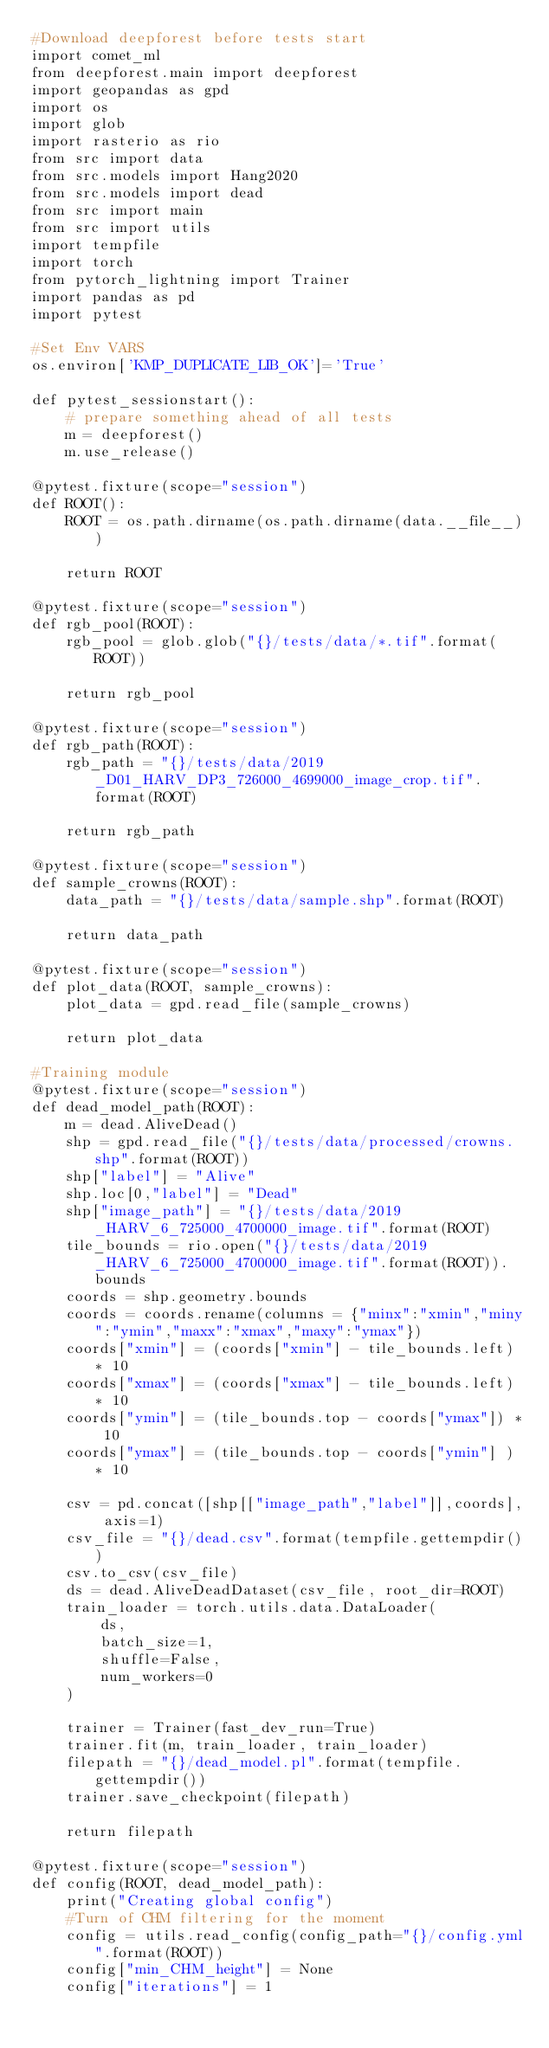Convert code to text. <code><loc_0><loc_0><loc_500><loc_500><_Python_>#Download deepforest before tests start
import comet_ml
from deepforest.main import deepforest
import geopandas as gpd
import os
import glob
import rasterio as rio
from src import data
from src.models import Hang2020
from src.models import dead
from src import main
from src import utils
import tempfile
import torch
from pytorch_lightning import Trainer
import pandas as pd
import pytest

#Set Env VARS
os.environ['KMP_DUPLICATE_LIB_OK']='True'

def pytest_sessionstart():
    # prepare something ahead of all tests
    m = deepforest()
    m.use_release()    

@pytest.fixture(scope="session")
def ROOT():
    ROOT = os.path.dirname(os.path.dirname(data.__file__))
    
    return ROOT

@pytest.fixture(scope="session")
def rgb_pool(ROOT):
    rgb_pool = glob.glob("{}/tests/data/*.tif".format(ROOT))
    
    return rgb_pool

@pytest.fixture(scope="session")
def rgb_path(ROOT):
    rgb_path = "{}/tests/data/2019_D01_HARV_DP3_726000_4699000_image_crop.tif".format(ROOT)
    
    return rgb_path

@pytest.fixture(scope="session")
def sample_crowns(ROOT):
    data_path = "{}/tests/data/sample.shp".format(ROOT)
    
    return data_path

@pytest.fixture(scope="session")
def plot_data(ROOT, sample_crowns):
    plot_data = gpd.read_file(sample_crowns)        
    
    return plot_data

#Training module
@pytest.fixture(scope="session")
def dead_model_path(ROOT):
    m = dead.AliveDead()
    shp = gpd.read_file("{}/tests/data/processed/crowns.shp".format(ROOT))
    shp["label"] = "Alive"
    shp.loc[0,"label"] = "Dead"
    shp["image_path"] = "{}/tests/data/2019_HARV_6_725000_4700000_image.tif".format(ROOT)
    tile_bounds = rio.open("{}/tests/data/2019_HARV_6_725000_4700000_image.tif".format(ROOT)).bounds 
    coords = shp.geometry.bounds
    coords = coords.rename(columns = {"minx":"xmin","miny":"ymin","maxx":"xmax","maxy":"ymax"})
    coords["xmin"] = (coords["xmin"] - tile_bounds.left) * 10
    coords["xmax"] = (coords["xmax"] - tile_bounds.left) * 10
    coords["ymin"] = (tile_bounds.top - coords["ymax"]) * 10
    coords["ymax"] = (tile_bounds.top - coords["ymin"] ) * 10
    
    csv = pd.concat([shp[["image_path","label"]],coords], axis=1)
    csv_file = "{}/dead.csv".format(tempfile.gettempdir())
    csv.to_csv(csv_file)
    ds = dead.AliveDeadDataset(csv_file, root_dir=ROOT)
    train_loader = torch.utils.data.DataLoader(
        ds,
        batch_size=1,
        shuffle=False,
        num_workers=0
    )     
    
    trainer = Trainer(fast_dev_run=True)
    trainer.fit(m, train_loader, train_loader)    
    filepath = "{}/dead_model.pl".format(tempfile.gettempdir())
    trainer.save_checkpoint(filepath)
    
    return filepath

@pytest.fixture(scope="session")
def config(ROOT, dead_model_path):
    print("Creating global config")
    #Turn of CHM filtering for the moment
    config = utils.read_config(config_path="{}/config.yml".format(ROOT))
    config["min_CHM_height"] = None
    config["iterations"] = 1</code> 